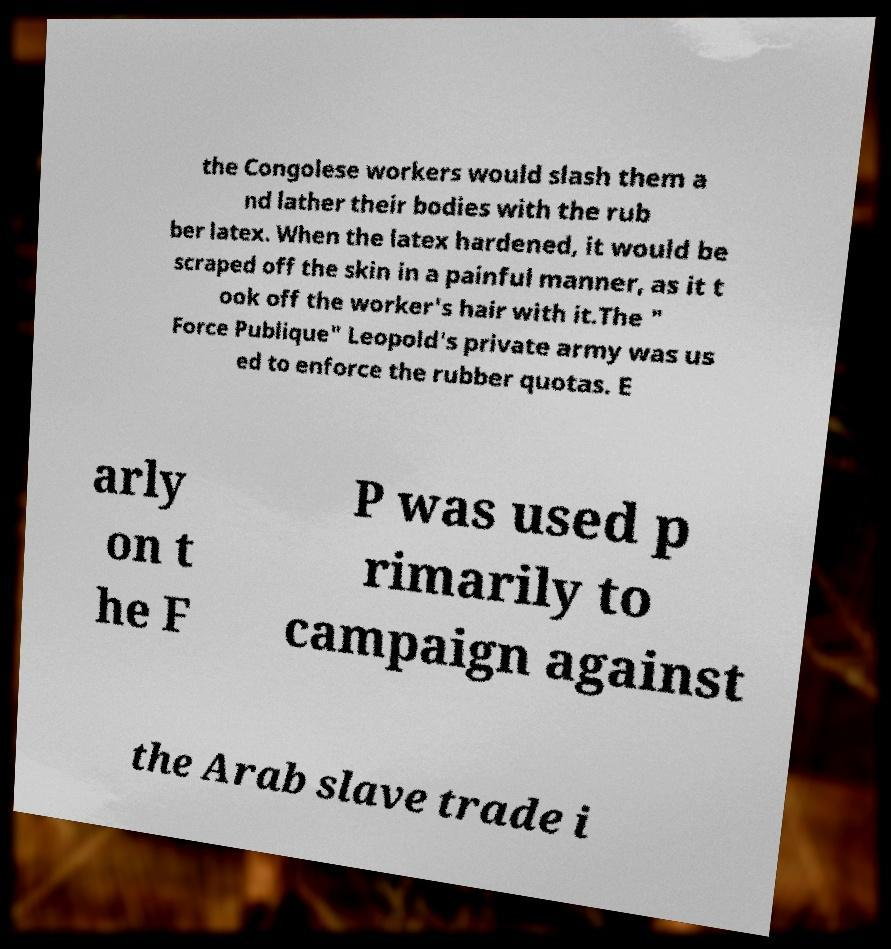For documentation purposes, I need the text within this image transcribed. Could you provide that? the Congolese workers would slash them a nd lather their bodies with the rub ber latex. When the latex hardened, it would be scraped off the skin in a painful manner, as it t ook off the worker's hair with it.The " Force Publique" Leopold's private army was us ed to enforce the rubber quotas. E arly on t he F P was used p rimarily to campaign against the Arab slave trade i 